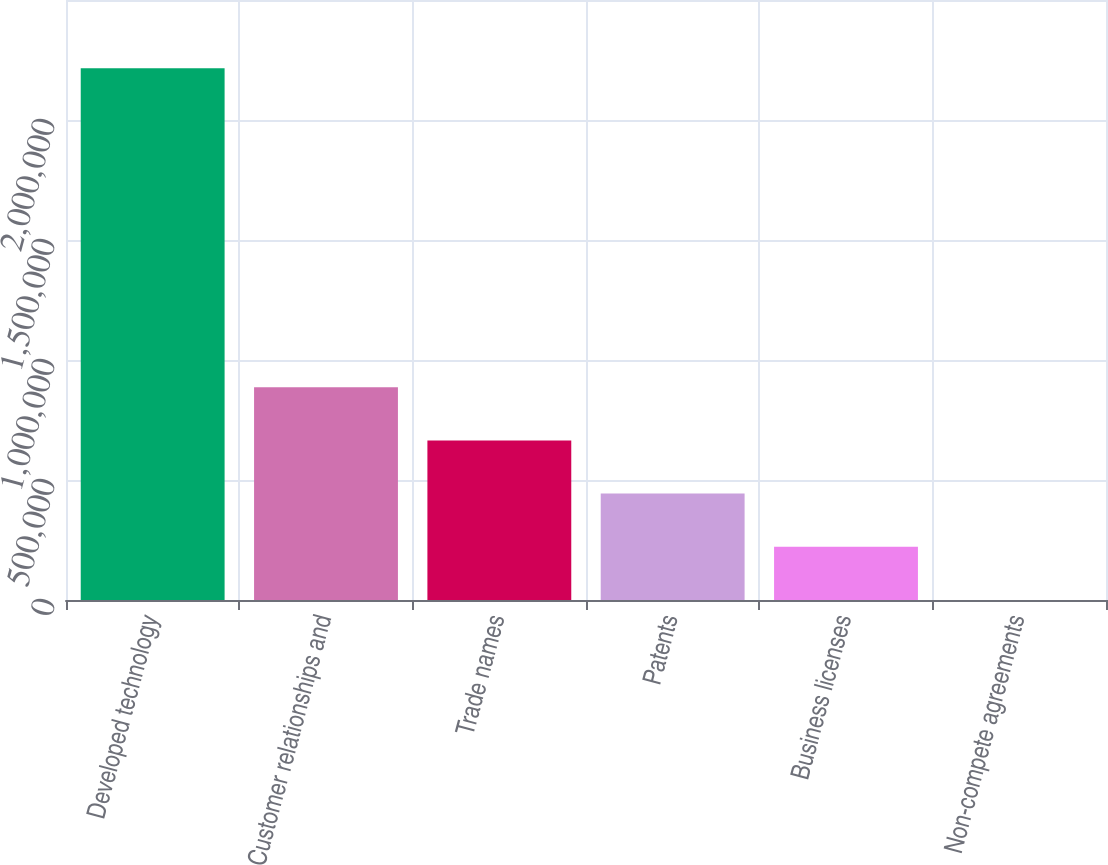<chart> <loc_0><loc_0><loc_500><loc_500><bar_chart><fcel>Developed technology<fcel>Customer relationships and<fcel>Trade names<fcel>Patents<fcel>Business licenses<fcel>Non-compete agreements<nl><fcel>2.21532e+06<fcel>886307<fcel>664805<fcel>443302<fcel>221800<fcel>297<nl></chart> 